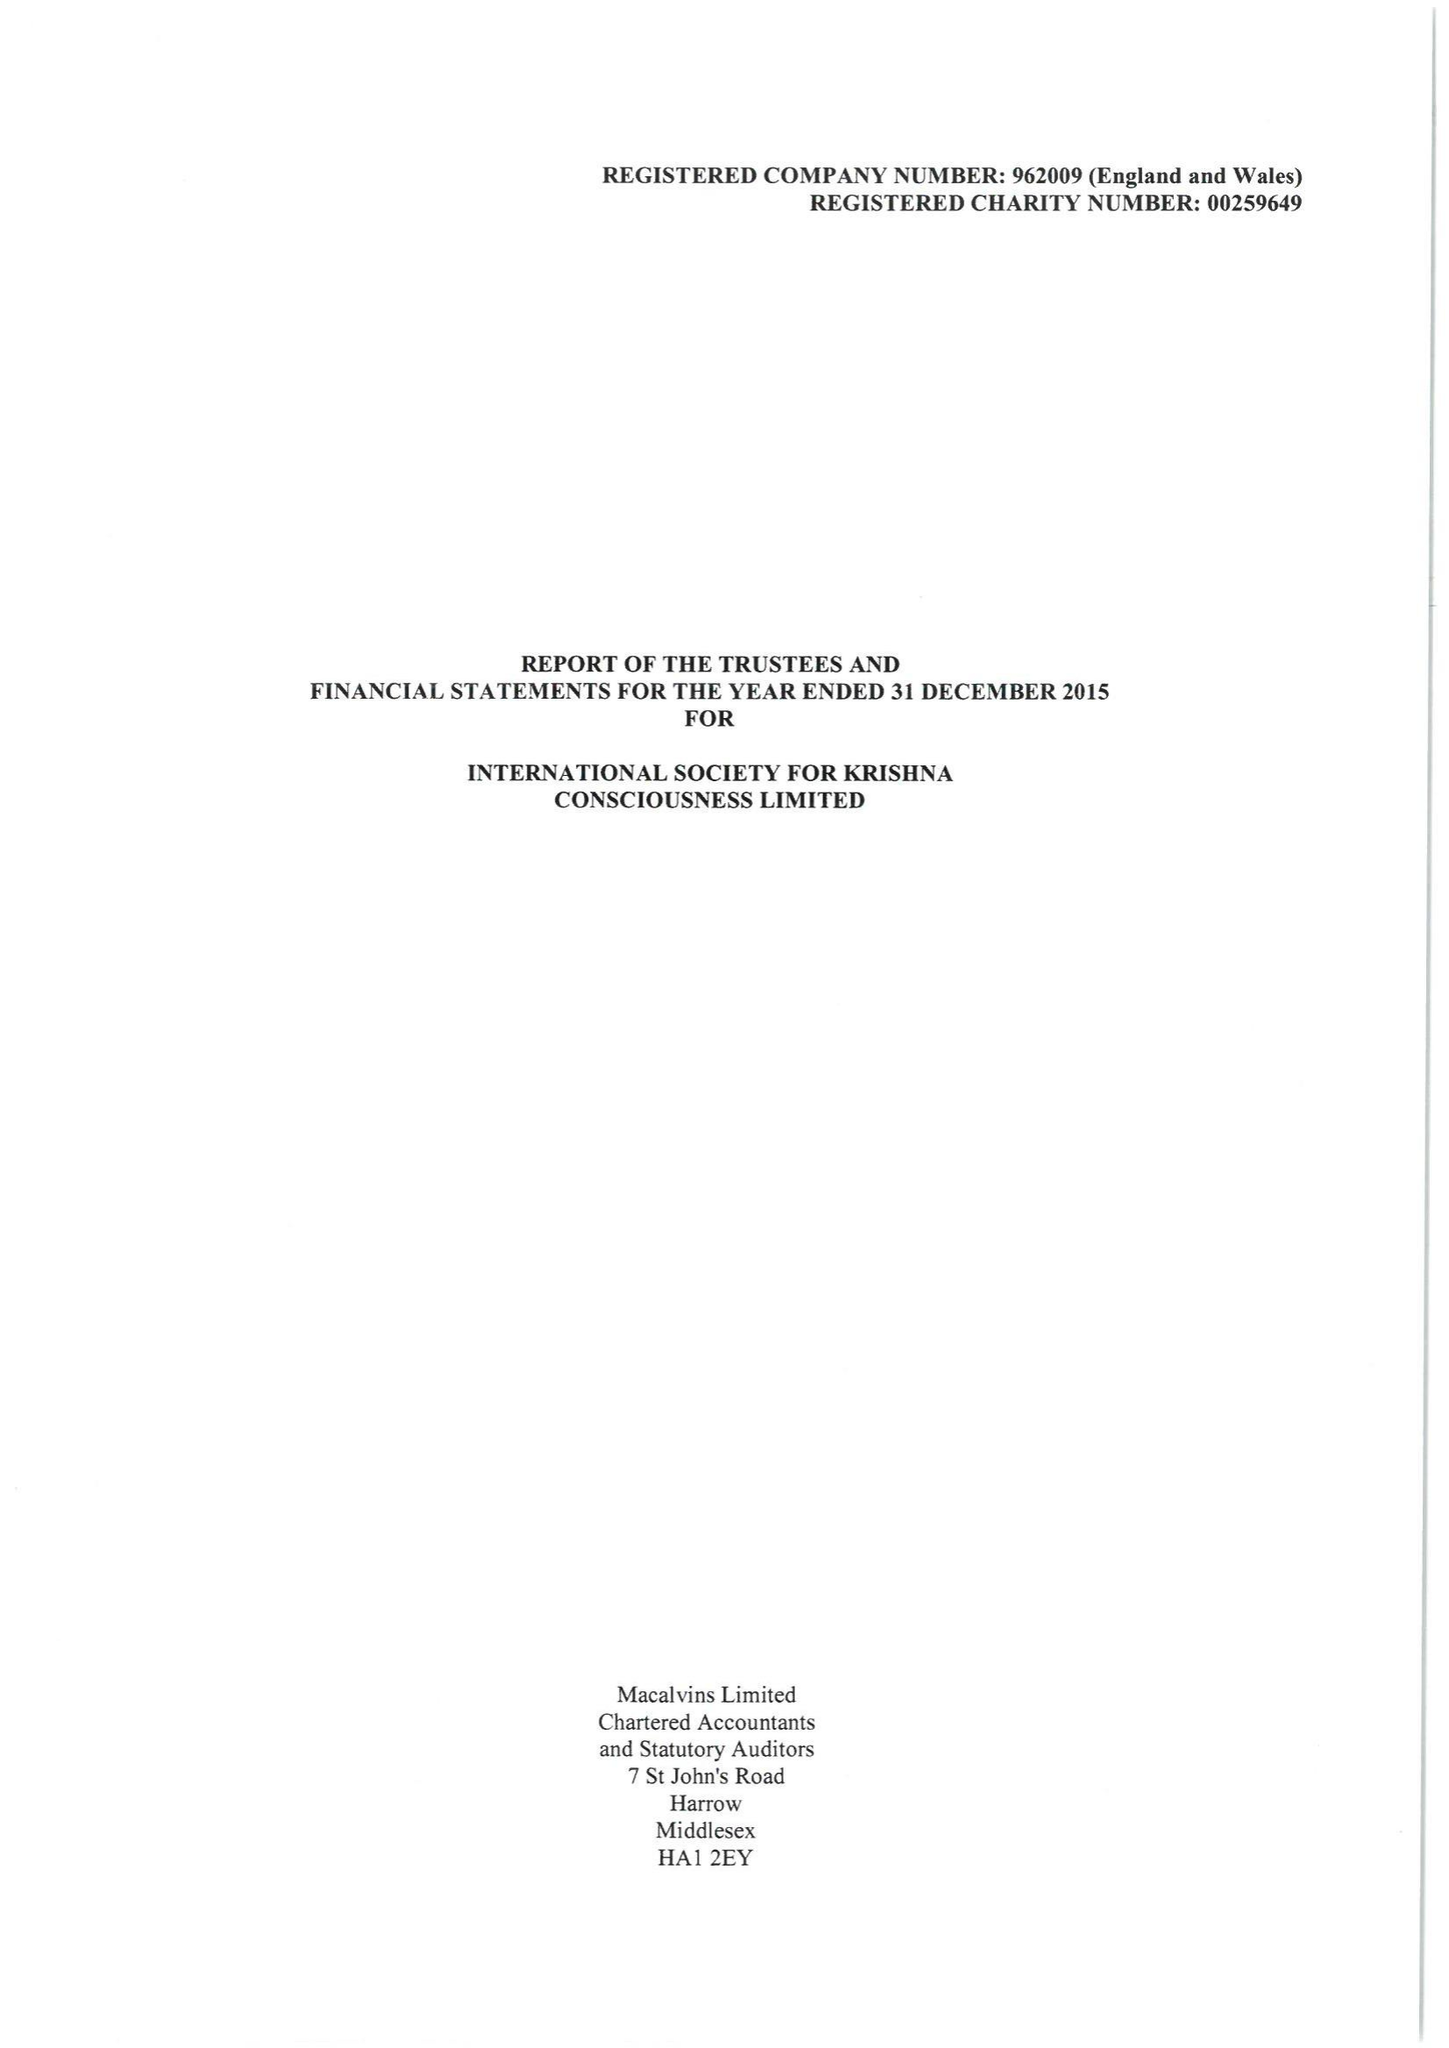What is the value for the report_date?
Answer the question using a single word or phrase. 2015-12-31 